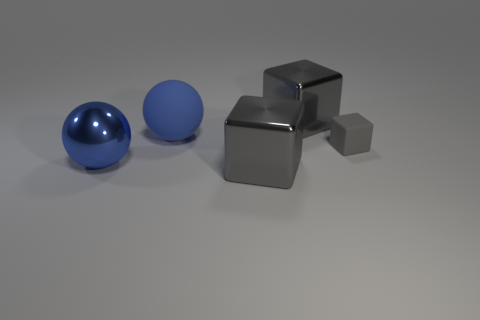Subtract all rubber cubes. How many cubes are left? 2 Subtract 1 spheres. How many spheres are left? 1 Add 3 large balls. How many objects exist? 8 Subtract all blocks. How many objects are left? 2 Add 2 rubber balls. How many rubber balls are left? 3 Add 1 small yellow matte cylinders. How many small yellow matte cylinders exist? 1 Subtract 0 red cubes. How many objects are left? 5 Subtract all blue cubes. Subtract all gray cylinders. How many cubes are left? 3 Subtract all tiny cubes. Subtract all tiny blue shiny objects. How many objects are left? 4 